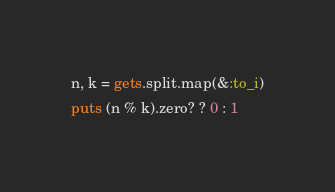Convert code to text. <code><loc_0><loc_0><loc_500><loc_500><_Ruby_>n, k = gets.split.map(&:to_i)
puts (n % k).zero? ? 0 : 1
</code> 